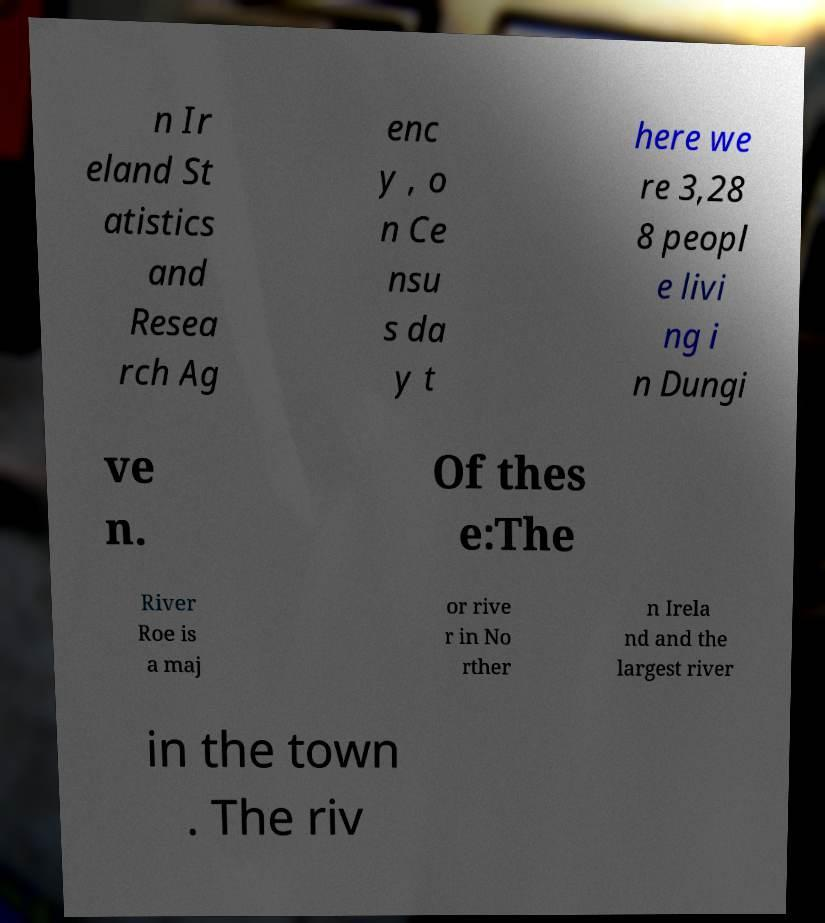Can you accurately transcribe the text from the provided image for me? n Ir eland St atistics and Resea rch Ag enc y , o n Ce nsu s da y t here we re 3,28 8 peopl e livi ng i n Dungi ve n. Of thes e:The River Roe is a maj or rive r in No rther n Irela nd and the largest river in the town . The riv 